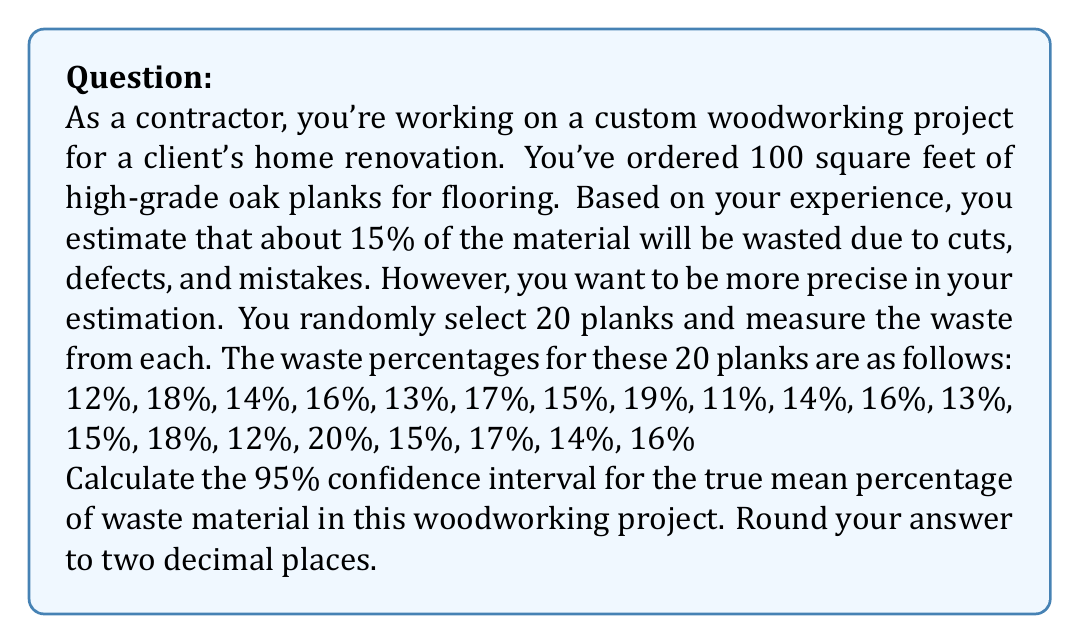Show me your answer to this math problem. To calculate the 95% confidence interval for the true mean percentage of waste material, we'll follow these steps:

1. Calculate the sample mean ($\bar{x}$):
   $$\bar{x} = \frac{\sum_{i=1}^{n} x_i}{n} = \frac{305}{20} = 15.25\%$$

2. Calculate the sample standard deviation ($s$):
   $$s = \sqrt{\frac{\sum_{i=1}^{n} (x_i - \bar{x})^2}{n-1}}$$
   $$s = \sqrt{\frac{178.75}{19}} \approx 2.4357\%$$

3. Determine the t-value for a 95% confidence interval with 19 degrees of freedom (n-1):
   $t_{0.025, 19} = 2.093$ (from t-distribution table)

4. Calculate the margin of error:
   $$\text{Margin of Error} = t_{0.025, 19} \cdot \frac{s}{\sqrt{n}} = 2.093 \cdot \frac{2.4357}{\sqrt{20}} \approx 1.1398\%$$

5. Compute the confidence interval:
   $$\text{CI} = \bar{x} \pm \text{Margin of Error}$$
   $$\text{CI} = 15.25\% \pm 1.1398\%$$
   $$\text{CI} = (14.1102\%, 16.3898\%)$$

6. Round to two decimal places:
   $$\text{CI} = (14.11\%, 16.39\%)$$
Answer: The 95% confidence interval for the true mean percentage of waste material in this woodworking project is (14.11%, 16.39%). 